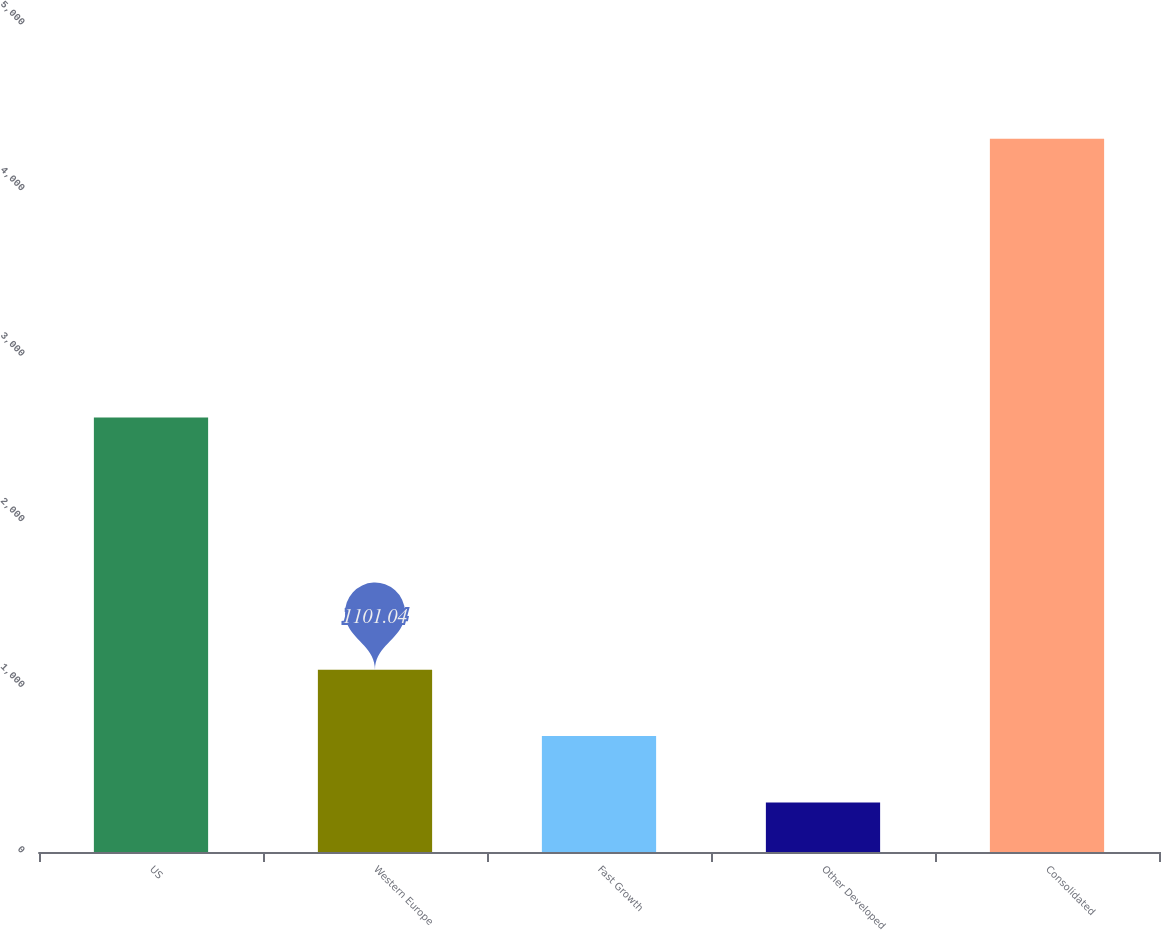<chart> <loc_0><loc_0><loc_500><loc_500><bar_chart><fcel>US<fcel>Western Europe<fcel>Fast Growth<fcel>Other Developed<fcel>Consolidated<nl><fcel>2624.3<fcel>1101.04<fcel>700.32<fcel>299.6<fcel>4306.8<nl></chart> 